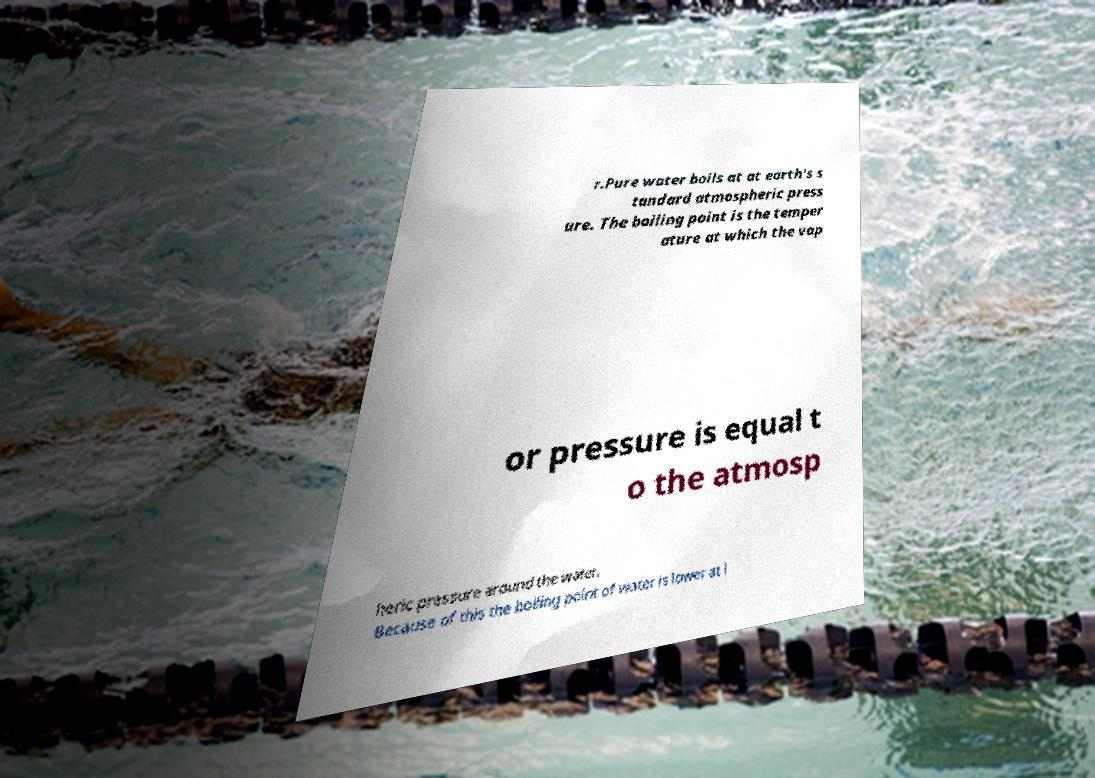Can you read and provide the text displayed in the image?This photo seems to have some interesting text. Can you extract and type it out for me? r.Pure water boils at at earth's s tandard atmospheric press ure. The boiling point is the temper ature at which the vap or pressure is equal t o the atmosp heric pressure around the water. Because of this the boiling point of water is lower at l 